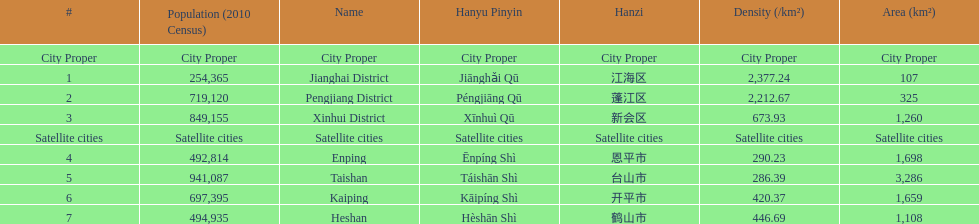Which area is the least dense? Taishan. 